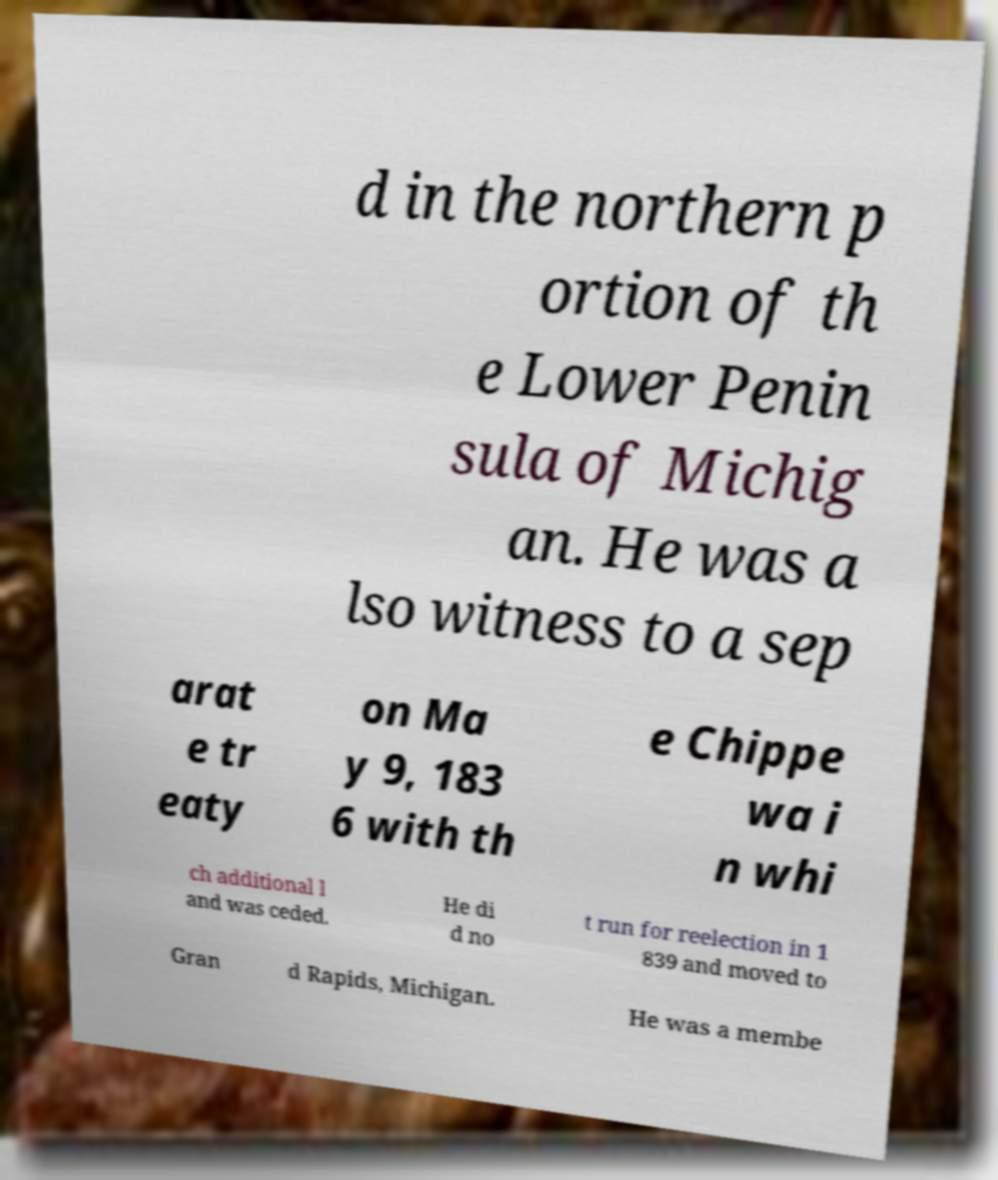Can you read and provide the text displayed in the image?This photo seems to have some interesting text. Can you extract and type it out for me? d in the northern p ortion of th e Lower Penin sula of Michig an. He was a lso witness to a sep arat e tr eaty on Ma y 9, 183 6 with th e Chippe wa i n whi ch additional l and was ceded. He di d no t run for reelection in 1 839 and moved to Gran d Rapids, Michigan. He was a membe 